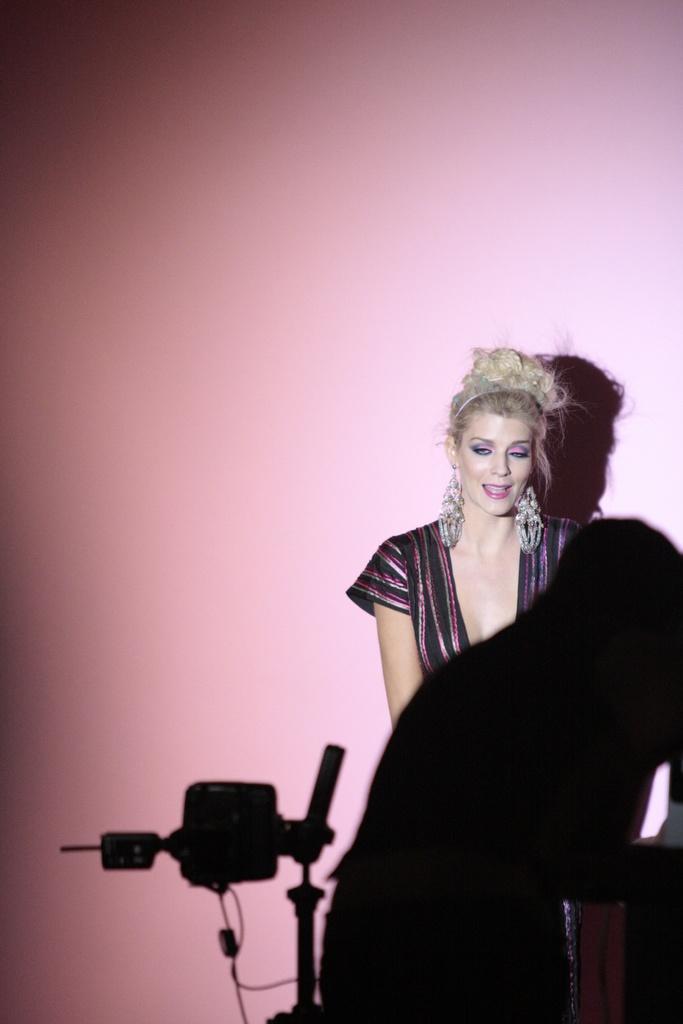Could you give a brief overview of what you see in this image? In-front of this pink we can see a woman. Front we can see a person. 